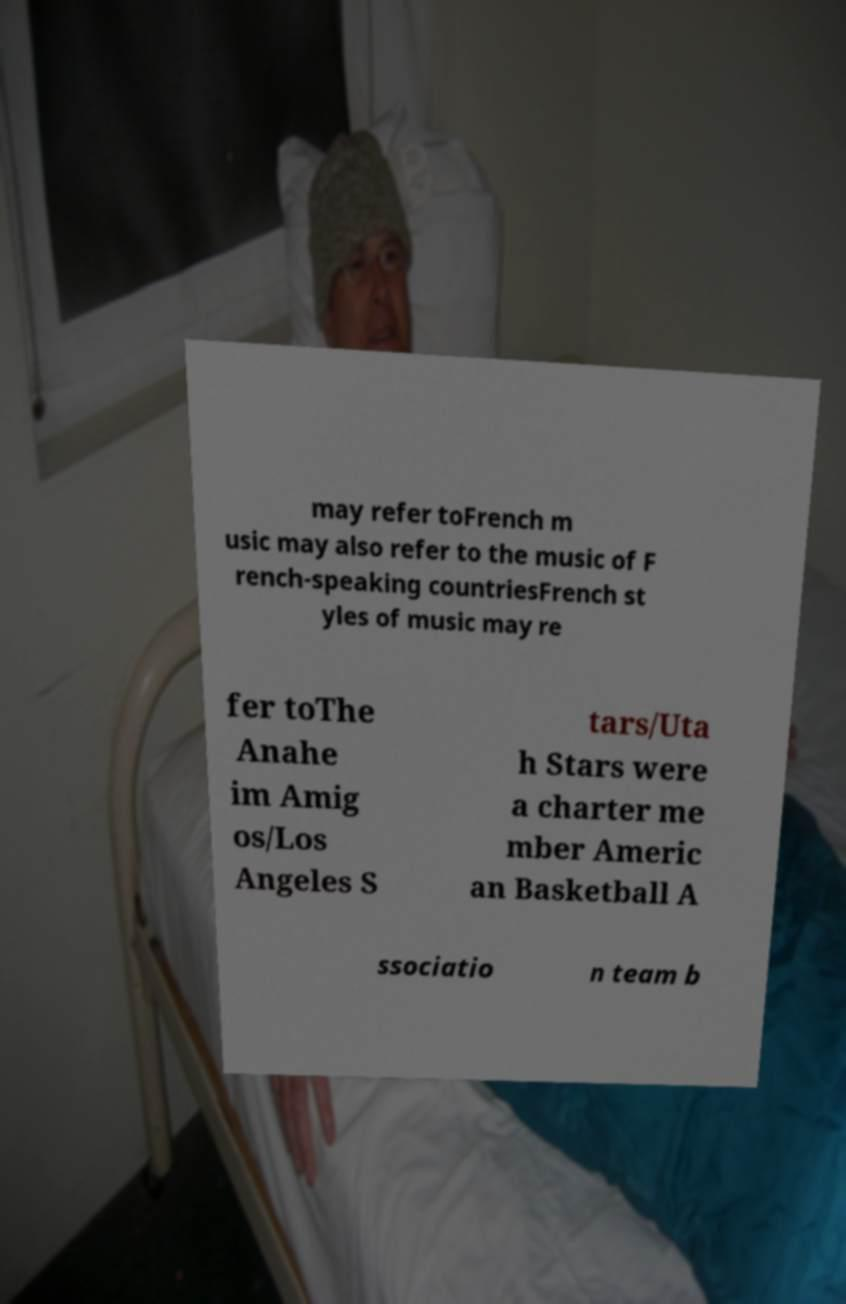Can you read and provide the text displayed in the image?This photo seems to have some interesting text. Can you extract and type it out for me? may refer toFrench m usic may also refer to the music of F rench-speaking countriesFrench st yles of music may re fer toThe Anahe im Amig os/Los Angeles S tars/Uta h Stars were a charter me mber Americ an Basketball A ssociatio n team b 